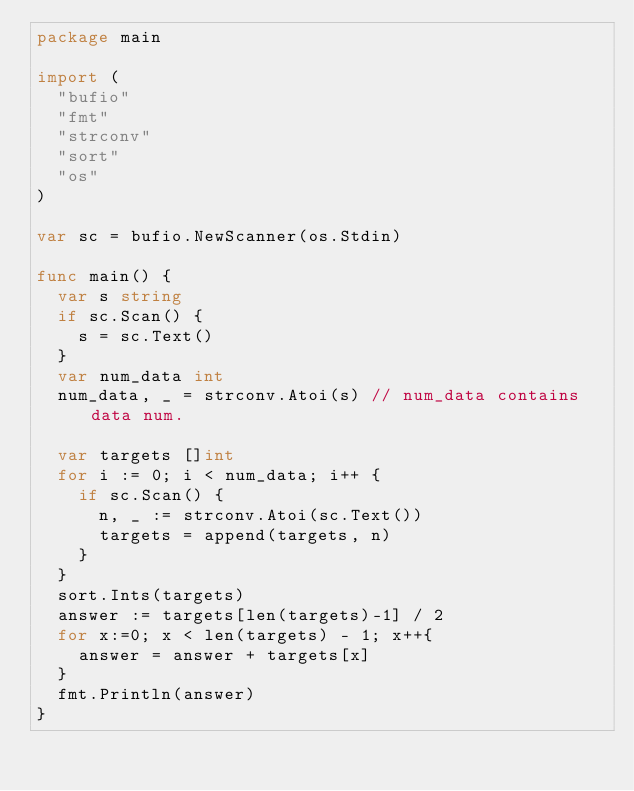Convert code to text. <code><loc_0><loc_0><loc_500><loc_500><_Go_>package main

import (
	"bufio"
	"fmt"
	"strconv"
	"sort"
	"os"
)

var sc = bufio.NewScanner(os.Stdin)

func main() {
	var s string
	if sc.Scan() {
		s = sc.Text()
	}
	var num_data int
	num_data, _ = strconv.Atoi(s) // num_data contains data num.

	var targets []int
	for i := 0; i < num_data; i++ {
		if sc.Scan() {
			n, _ := strconv.Atoi(sc.Text())
			targets = append(targets, n)
		}
	}
	sort.Ints(targets)
	answer := targets[len(targets)-1] / 2
	for x:=0; x < len(targets) - 1; x++{
		answer = answer + targets[x]
	}
	fmt.Println(answer)
}
</code> 